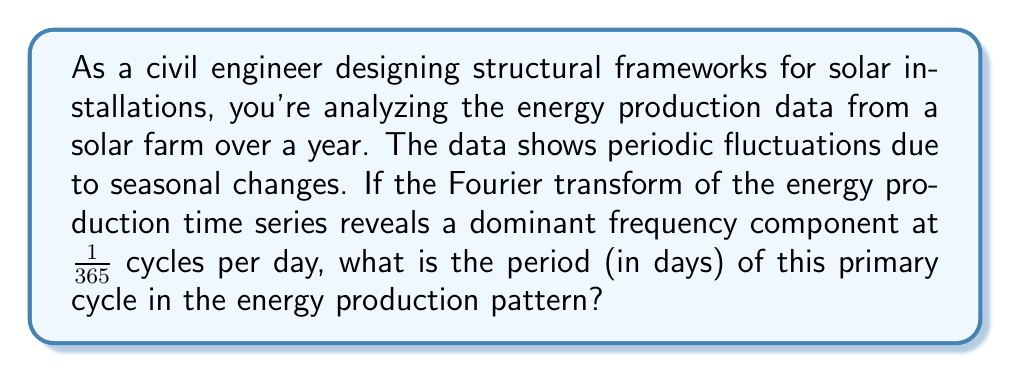Teach me how to tackle this problem. To solve this problem, we need to understand the relationship between frequency and period in time series analysis:

1) In Fourier analysis, frequency ($f$) is the number of cycles per unit time.

2) Period ($T$) is the time taken for one complete cycle.

3) The relationship between frequency and period is:

   $$f = \frac{1}{T}$$

4) In this case, the frequency is given as $\frac{1}{365}$ cycles per day.

5) To find the period, we need to invert this relationship:

   $$T = \frac{1}{f}$$

6) Substituting the given frequency:

   $$T = \frac{1}{\frac{1}{365}} = 365$$

7) Therefore, the period of the primary cycle is 365 days.

This result aligns with our intuition about solar energy production: the dominant cycle in a year-long time series is likely to be the annual cycle, reflecting seasonal changes in solar intensity and daylight hours.
Answer: 365 days 